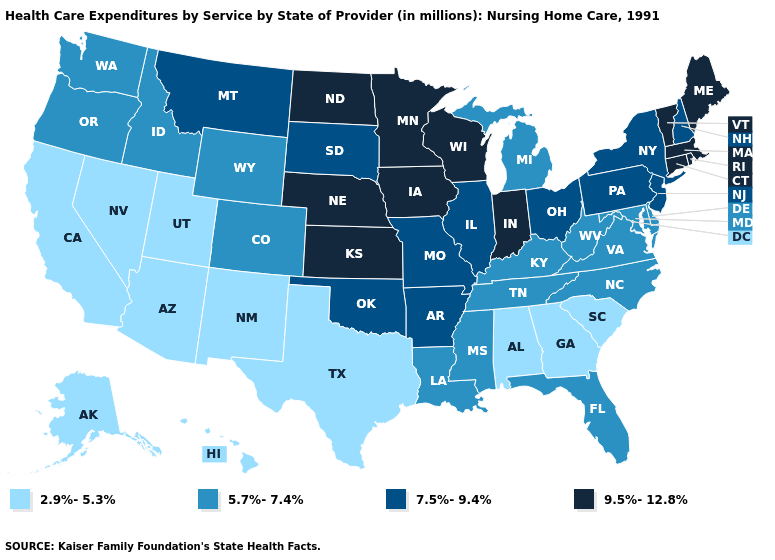Name the states that have a value in the range 9.5%-12.8%?
Short answer required. Connecticut, Indiana, Iowa, Kansas, Maine, Massachusetts, Minnesota, Nebraska, North Dakota, Rhode Island, Vermont, Wisconsin. Name the states that have a value in the range 7.5%-9.4%?
Give a very brief answer. Arkansas, Illinois, Missouri, Montana, New Hampshire, New Jersey, New York, Ohio, Oklahoma, Pennsylvania, South Dakota. What is the lowest value in the West?
Short answer required. 2.9%-5.3%. What is the value of Nevada?
Answer briefly. 2.9%-5.3%. What is the lowest value in the MidWest?
Give a very brief answer. 5.7%-7.4%. What is the lowest value in the USA?
Concise answer only. 2.9%-5.3%. Does California have the lowest value in the USA?
Answer briefly. Yes. Name the states that have a value in the range 9.5%-12.8%?
Answer briefly. Connecticut, Indiana, Iowa, Kansas, Maine, Massachusetts, Minnesota, Nebraska, North Dakota, Rhode Island, Vermont, Wisconsin. Does New Mexico have a lower value than Minnesota?
Be succinct. Yes. Name the states that have a value in the range 2.9%-5.3%?
Concise answer only. Alabama, Alaska, Arizona, California, Georgia, Hawaii, Nevada, New Mexico, South Carolina, Texas, Utah. Does the map have missing data?
Keep it brief. No. Name the states that have a value in the range 9.5%-12.8%?
Keep it brief. Connecticut, Indiana, Iowa, Kansas, Maine, Massachusetts, Minnesota, Nebraska, North Dakota, Rhode Island, Vermont, Wisconsin. What is the value of Maine?
Give a very brief answer. 9.5%-12.8%. Does the map have missing data?
Be succinct. No. 